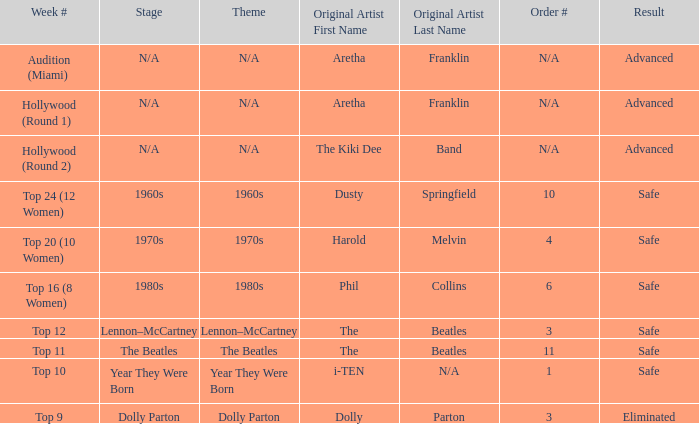What is the week number with Phil Collins as the original artist? Top 16 (8 Women). 